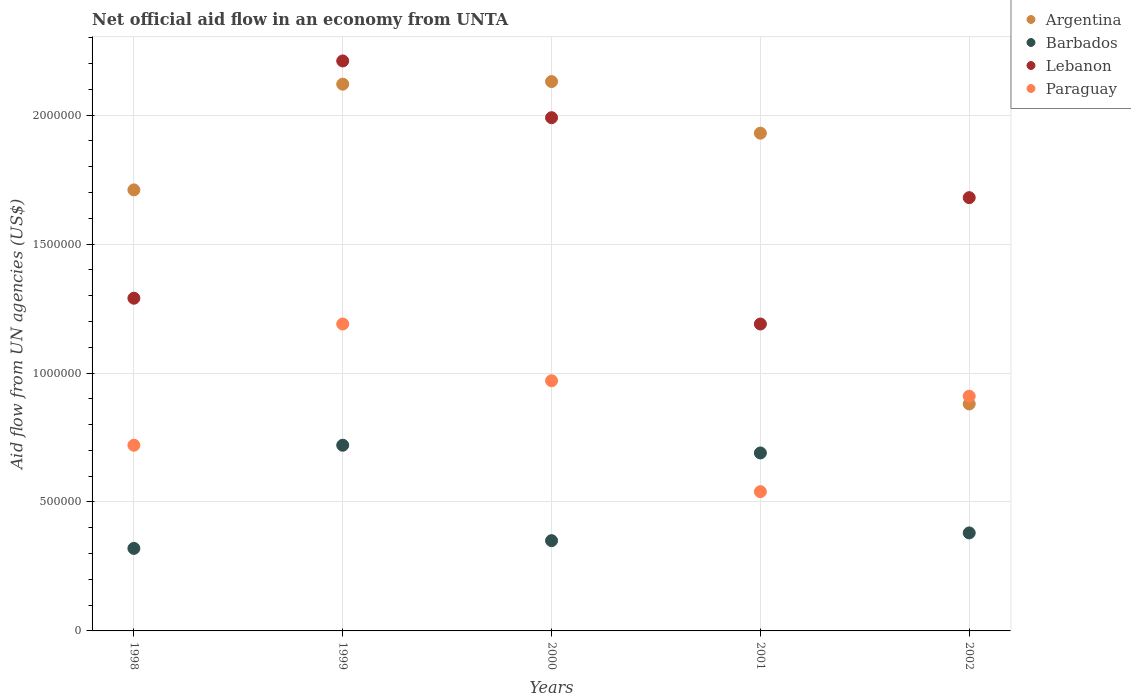Is the number of dotlines equal to the number of legend labels?
Keep it short and to the point. Yes. What is the net official aid flow in Paraguay in 2000?
Ensure brevity in your answer.  9.70e+05. Across all years, what is the maximum net official aid flow in Paraguay?
Ensure brevity in your answer.  1.19e+06. Across all years, what is the minimum net official aid flow in Paraguay?
Provide a succinct answer. 5.40e+05. In which year was the net official aid flow in Barbados minimum?
Make the answer very short. 1998. What is the total net official aid flow in Argentina in the graph?
Ensure brevity in your answer.  8.77e+06. What is the difference between the net official aid flow in Lebanon in 1998 and that in 2002?
Keep it short and to the point. -3.90e+05. What is the difference between the net official aid flow in Barbados in 2002 and the net official aid flow in Paraguay in 2000?
Give a very brief answer. -5.90e+05. What is the average net official aid flow in Argentina per year?
Ensure brevity in your answer.  1.75e+06. In the year 1998, what is the difference between the net official aid flow in Lebanon and net official aid flow in Argentina?
Make the answer very short. -4.20e+05. What is the ratio of the net official aid flow in Barbados in 2000 to that in 2002?
Provide a succinct answer. 0.92. Is the net official aid flow in Barbados in 2001 less than that in 2002?
Provide a short and direct response. No. Is the difference between the net official aid flow in Lebanon in 1998 and 2001 greater than the difference between the net official aid flow in Argentina in 1998 and 2001?
Give a very brief answer. Yes. What is the difference between the highest and the second highest net official aid flow in Lebanon?
Your answer should be compact. 2.20e+05. What is the difference between the highest and the lowest net official aid flow in Lebanon?
Your response must be concise. 1.02e+06. In how many years, is the net official aid flow in Argentina greater than the average net official aid flow in Argentina taken over all years?
Your answer should be very brief. 3. Is it the case that in every year, the sum of the net official aid flow in Argentina and net official aid flow in Barbados  is greater than the net official aid flow in Lebanon?
Provide a succinct answer. No. Is the net official aid flow in Barbados strictly greater than the net official aid flow in Argentina over the years?
Your response must be concise. No. Does the graph contain any zero values?
Offer a very short reply. No. Where does the legend appear in the graph?
Ensure brevity in your answer.  Top right. What is the title of the graph?
Keep it short and to the point. Net official aid flow in an economy from UNTA. What is the label or title of the X-axis?
Your response must be concise. Years. What is the label or title of the Y-axis?
Provide a short and direct response. Aid flow from UN agencies (US$). What is the Aid flow from UN agencies (US$) of Argentina in 1998?
Offer a very short reply. 1.71e+06. What is the Aid flow from UN agencies (US$) of Lebanon in 1998?
Offer a terse response. 1.29e+06. What is the Aid flow from UN agencies (US$) in Paraguay in 1998?
Your response must be concise. 7.20e+05. What is the Aid flow from UN agencies (US$) in Argentina in 1999?
Provide a succinct answer. 2.12e+06. What is the Aid flow from UN agencies (US$) of Barbados in 1999?
Make the answer very short. 7.20e+05. What is the Aid flow from UN agencies (US$) of Lebanon in 1999?
Keep it short and to the point. 2.21e+06. What is the Aid flow from UN agencies (US$) in Paraguay in 1999?
Your response must be concise. 1.19e+06. What is the Aid flow from UN agencies (US$) in Argentina in 2000?
Ensure brevity in your answer.  2.13e+06. What is the Aid flow from UN agencies (US$) of Lebanon in 2000?
Provide a succinct answer. 1.99e+06. What is the Aid flow from UN agencies (US$) in Paraguay in 2000?
Your answer should be compact. 9.70e+05. What is the Aid flow from UN agencies (US$) of Argentina in 2001?
Provide a short and direct response. 1.93e+06. What is the Aid flow from UN agencies (US$) in Barbados in 2001?
Make the answer very short. 6.90e+05. What is the Aid flow from UN agencies (US$) of Lebanon in 2001?
Your answer should be very brief. 1.19e+06. What is the Aid flow from UN agencies (US$) in Paraguay in 2001?
Provide a short and direct response. 5.40e+05. What is the Aid flow from UN agencies (US$) in Argentina in 2002?
Give a very brief answer. 8.80e+05. What is the Aid flow from UN agencies (US$) in Lebanon in 2002?
Provide a succinct answer. 1.68e+06. What is the Aid flow from UN agencies (US$) in Paraguay in 2002?
Your answer should be compact. 9.10e+05. Across all years, what is the maximum Aid flow from UN agencies (US$) in Argentina?
Give a very brief answer. 2.13e+06. Across all years, what is the maximum Aid flow from UN agencies (US$) in Barbados?
Make the answer very short. 7.20e+05. Across all years, what is the maximum Aid flow from UN agencies (US$) of Lebanon?
Offer a terse response. 2.21e+06. Across all years, what is the maximum Aid flow from UN agencies (US$) in Paraguay?
Provide a succinct answer. 1.19e+06. Across all years, what is the minimum Aid flow from UN agencies (US$) in Argentina?
Your answer should be very brief. 8.80e+05. Across all years, what is the minimum Aid flow from UN agencies (US$) of Lebanon?
Ensure brevity in your answer.  1.19e+06. Across all years, what is the minimum Aid flow from UN agencies (US$) in Paraguay?
Ensure brevity in your answer.  5.40e+05. What is the total Aid flow from UN agencies (US$) of Argentina in the graph?
Your answer should be very brief. 8.77e+06. What is the total Aid flow from UN agencies (US$) in Barbados in the graph?
Ensure brevity in your answer.  2.46e+06. What is the total Aid flow from UN agencies (US$) in Lebanon in the graph?
Provide a short and direct response. 8.36e+06. What is the total Aid flow from UN agencies (US$) in Paraguay in the graph?
Offer a terse response. 4.33e+06. What is the difference between the Aid flow from UN agencies (US$) in Argentina in 1998 and that in 1999?
Provide a succinct answer. -4.10e+05. What is the difference between the Aid flow from UN agencies (US$) in Barbados in 1998 and that in 1999?
Give a very brief answer. -4.00e+05. What is the difference between the Aid flow from UN agencies (US$) in Lebanon in 1998 and that in 1999?
Your response must be concise. -9.20e+05. What is the difference between the Aid flow from UN agencies (US$) of Paraguay in 1998 and that in 1999?
Give a very brief answer. -4.70e+05. What is the difference between the Aid flow from UN agencies (US$) of Argentina in 1998 and that in 2000?
Make the answer very short. -4.20e+05. What is the difference between the Aid flow from UN agencies (US$) in Barbados in 1998 and that in 2000?
Your answer should be very brief. -3.00e+04. What is the difference between the Aid flow from UN agencies (US$) of Lebanon in 1998 and that in 2000?
Keep it short and to the point. -7.00e+05. What is the difference between the Aid flow from UN agencies (US$) in Argentina in 1998 and that in 2001?
Provide a short and direct response. -2.20e+05. What is the difference between the Aid flow from UN agencies (US$) of Barbados in 1998 and that in 2001?
Give a very brief answer. -3.70e+05. What is the difference between the Aid flow from UN agencies (US$) in Lebanon in 1998 and that in 2001?
Give a very brief answer. 1.00e+05. What is the difference between the Aid flow from UN agencies (US$) of Argentina in 1998 and that in 2002?
Provide a succinct answer. 8.30e+05. What is the difference between the Aid flow from UN agencies (US$) of Barbados in 1998 and that in 2002?
Provide a succinct answer. -6.00e+04. What is the difference between the Aid flow from UN agencies (US$) of Lebanon in 1998 and that in 2002?
Keep it short and to the point. -3.90e+05. What is the difference between the Aid flow from UN agencies (US$) in Lebanon in 1999 and that in 2000?
Provide a short and direct response. 2.20e+05. What is the difference between the Aid flow from UN agencies (US$) in Paraguay in 1999 and that in 2000?
Your response must be concise. 2.20e+05. What is the difference between the Aid flow from UN agencies (US$) of Barbados in 1999 and that in 2001?
Your answer should be very brief. 3.00e+04. What is the difference between the Aid flow from UN agencies (US$) of Lebanon in 1999 and that in 2001?
Keep it short and to the point. 1.02e+06. What is the difference between the Aid flow from UN agencies (US$) of Paraguay in 1999 and that in 2001?
Give a very brief answer. 6.50e+05. What is the difference between the Aid flow from UN agencies (US$) of Argentina in 1999 and that in 2002?
Offer a terse response. 1.24e+06. What is the difference between the Aid flow from UN agencies (US$) in Barbados in 1999 and that in 2002?
Offer a terse response. 3.40e+05. What is the difference between the Aid flow from UN agencies (US$) in Lebanon in 1999 and that in 2002?
Offer a very short reply. 5.30e+05. What is the difference between the Aid flow from UN agencies (US$) of Paraguay in 1999 and that in 2002?
Offer a terse response. 2.80e+05. What is the difference between the Aid flow from UN agencies (US$) in Argentina in 2000 and that in 2001?
Ensure brevity in your answer.  2.00e+05. What is the difference between the Aid flow from UN agencies (US$) of Barbados in 2000 and that in 2001?
Your answer should be very brief. -3.40e+05. What is the difference between the Aid flow from UN agencies (US$) of Lebanon in 2000 and that in 2001?
Ensure brevity in your answer.  8.00e+05. What is the difference between the Aid flow from UN agencies (US$) of Argentina in 2000 and that in 2002?
Ensure brevity in your answer.  1.25e+06. What is the difference between the Aid flow from UN agencies (US$) in Argentina in 2001 and that in 2002?
Ensure brevity in your answer.  1.05e+06. What is the difference between the Aid flow from UN agencies (US$) in Lebanon in 2001 and that in 2002?
Your answer should be very brief. -4.90e+05. What is the difference between the Aid flow from UN agencies (US$) in Paraguay in 2001 and that in 2002?
Your response must be concise. -3.70e+05. What is the difference between the Aid flow from UN agencies (US$) in Argentina in 1998 and the Aid flow from UN agencies (US$) in Barbados in 1999?
Your answer should be compact. 9.90e+05. What is the difference between the Aid flow from UN agencies (US$) of Argentina in 1998 and the Aid flow from UN agencies (US$) of Lebanon in 1999?
Offer a very short reply. -5.00e+05. What is the difference between the Aid flow from UN agencies (US$) in Argentina in 1998 and the Aid flow from UN agencies (US$) in Paraguay in 1999?
Your answer should be very brief. 5.20e+05. What is the difference between the Aid flow from UN agencies (US$) in Barbados in 1998 and the Aid flow from UN agencies (US$) in Lebanon in 1999?
Ensure brevity in your answer.  -1.89e+06. What is the difference between the Aid flow from UN agencies (US$) in Barbados in 1998 and the Aid flow from UN agencies (US$) in Paraguay in 1999?
Provide a short and direct response. -8.70e+05. What is the difference between the Aid flow from UN agencies (US$) of Lebanon in 1998 and the Aid flow from UN agencies (US$) of Paraguay in 1999?
Your answer should be very brief. 1.00e+05. What is the difference between the Aid flow from UN agencies (US$) of Argentina in 1998 and the Aid flow from UN agencies (US$) of Barbados in 2000?
Your answer should be very brief. 1.36e+06. What is the difference between the Aid flow from UN agencies (US$) of Argentina in 1998 and the Aid flow from UN agencies (US$) of Lebanon in 2000?
Give a very brief answer. -2.80e+05. What is the difference between the Aid flow from UN agencies (US$) in Argentina in 1998 and the Aid flow from UN agencies (US$) in Paraguay in 2000?
Make the answer very short. 7.40e+05. What is the difference between the Aid flow from UN agencies (US$) of Barbados in 1998 and the Aid flow from UN agencies (US$) of Lebanon in 2000?
Your response must be concise. -1.67e+06. What is the difference between the Aid flow from UN agencies (US$) of Barbados in 1998 and the Aid flow from UN agencies (US$) of Paraguay in 2000?
Keep it short and to the point. -6.50e+05. What is the difference between the Aid flow from UN agencies (US$) in Lebanon in 1998 and the Aid flow from UN agencies (US$) in Paraguay in 2000?
Provide a short and direct response. 3.20e+05. What is the difference between the Aid flow from UN agencies (US$) of Argentina in 1998 and the Aid flow from UN agencies (US$) of Barbados in 2001?
Provide a succinct answer. 1.02e+06. What is the difference between the Aid flow from UN agencies (US$) in Argentina in 1998 and the Aid flow from UN agencies (US$) in Lebanon in 2001?
Your response must be concise. 5.20e+05. What is the difference between the Aid flow from UN agencies (US$) of Argentina in 1998 and the Aid flow from UN agencies (US$) of Paraguay in 2001?
Offer a terse response. 1.17e+06. What is the difference between the Aid flow from UN agencies (US$) of Barbados in 1998 and the Aid flow from UN agencies (US$) of Lebanon in 2001?
Your answer should be compact. -8.70e+05. What is the difference between the Aid flow from UN agencies (US$) of Lebanon in 1998 and the Aid flow from UN agencies (US$) of Paraguay in 2001?
Offer a very short reply. 7.50e+05. What is the difference between the Aid flow from UN agencies (US$) in Argentina in 1998 and the Aid flow from UN agencies (US$) in Barbados in 2002?
Make the answer very short. 1.33e+06. What is the difference between the Aid flow from UN agencies (US$) in Argentina in 1998 and the Aid flow from UN agencies (US$) in Lebanon in 2002?
Keep it short and to the point. 3.00e+04. What is the difference between the Aid flow from UN agencies (US$) in Barbados in 1998 and the Aid flow from UN agencies (US$) in Lebanon in 2002?
Provide a short and direct response. -1.36e+06. What is the difference between the Aid flow from UN agencies (US$) in Barbados in 1998 and the Aid flow from UN agencies (US$) in Paraguay in 2002?
Provide a short and direct response. -5.90e+05. What is the difference between the Aid flow from UN agencies (US$) in Lebanon in 1998 and the Aid flow from UN agencies (US$) in Paraguay in 2002?
Give a very brief answer. 3.80e+05. What is the difference between the Aid flow from UN agencies (US$) in Argentina in 1999 and the Aid flow from UN agencies (US$) in Barbados in 2000?
Keep it short and to the point. 1.77e+06. What is the difference between the Aid flow from UN agencies (US$) in Argentina in 1999 and the Aid flow from UN agencies (US$) in Lebanon in 2000?
Provide a succinct answer. 1.30e+05. What is the difference between the Aid flow from UN agencies (US$) of Argentina in 1999 and the Aid flow from UN agencies (US$) of Paraguay in 2000?
Your answer should be compact. 1.15e+06. What is the difference between the Aid flow from UN agencies (US$) in Barbados in 1999 and the Aid flow from UN agencies (US$) in Lebanon in 2000?
Give a very brief answer. -1.27e+06. What is the difference between the Aid flow from UN agencies (US$) in Barbados in 1999 and the Aid flow from UN agencies (US$) in Paraguay in 2000?
Make the answer very short. -2.50e+05. What is the difference between the Aid flow from UN agencies (US$) in Lebanon in 1999 and the Aid flow from UN agencies (US$) in Paraguay in 2000?
Provide a short and direct response. 1.24e+06. What is the difference between the Aid flow from UN agencies (US$) of Argentina in 1999 and the Aid flow from UN agencies (US$) of Barbados in 2001?
Offer a terse response. 1.43e+06. What is the difference between the Aid flow from UN agencies (US$) of Argentina in 1999 and the Aid flow from UN agencies (US$) of Lebanon in 2001?
Provide a succinct answer. 9.30e+05. What is the difference between the Aid flow from UN agencies (US$) in Argentina in 1999 and the Aid flow from UN agencies (US$) in Paraguay in 2001?
Offer a terse response. 1.58e+06. What is the difference between the Aid flow from UN agencies (US$) in Barbados in 1999 and the Aid flow from UN agencies (US$) in Lebanon in 2001?
Your response must be concise. -4.70e+05. What is the difference between the Aid flow from UN agencies (US$) of Lebanon in 1999 and the Aid flow from UN agencies (US$) of Paraguay in 2001?
Make the answer very short. 1.67e+06. What is the difference between the Aid flow from UN agencies (US$) in Argentina in 1999 and the Aid flow from UN agencies (US$) in Barbados in 2002?
Offer a terse response. 1.74e+06. What is the difference between the Aid flow from UN agencies (US$) in Argentina in 1999 and the Aid flow from UN agencies (US$) in Lebanon in 2002?
Ensure brevity in your answer.  4.40e+05. What is the difference between the Aid flow from UN agencies (US$) of Argentina in 1999 and the Aid flow from UN agencies (US$) of Paraguay in 2002?
Your answer should be very brief. 1.21e+06. What is the difference between the Aid flow from UN agencies (US$) of Barbados in 1999 and the Aid flow from UN agencies (US$) of Lebanon in 2002?
Provide a succinct answer. -9.60e+05. What is the difference between the Aid flow from UN agencies (US$) of Barbados in 1999 and the Aid flow from UN agencies (US$) of Paraguay in 2002?
Make the answer very short. -1.90e+05. What is the difference between the Aid flow from UN agencies (US$) in Lebanon in 1999 and the Aid flow from UN agencies (US$) in Paraguay in 2002?
Provide a short and direct response. 1.30e+06. What is the difference between the Aid flow from UN agencies (US$) of Argentina in 2000 and the Aid flow from UN agencies (US$) of Barbados in 2001?
Your answer should be very brief. 1.44e+06. What is the difference between the Aid flow from UN agencies (US$) in Argentina in 2000 and the Aid flow from UN agencies (US$) in Lebanon in 2001?
Give a very brief answer. 9.40e+05. What is the difference between the Aid flow from UN agencies (US$) of Argentina in 2000 and the Aid flow from UN agencies (US$) of Paraguay in 2001?
Your response must be concise. 1.59e+06. What is the difference between the Aid flow from UN agencies (US$) of Barbados in 2000 and the Aid flow from UN agencies (US$) of Lebanon in 2001?
Your answer should be very brief. -8.40e+05. What is the difference between the Aid flow from UN agencies (US$) in Lebanon in 2000 and the Aid flow from UN agencies (US$) in Paraguay in 2001?
Provide a succinct answer. 1.45e+06. What is the difference between the Aid flow from UN agencies (US$) of Argentina in 2000 and the Aid flow from UN agencies (US$) of Barbados in 2002?
Offer a terse response. 1.75e+06. What is the difference between the Aid flow from UN agencies (US$) of Argentina in 2000 and the Aid flow from UN agencies (US$) of Lebanon in 2002?
Offer a very short reply. 4.50e+05. What is the difference between the Aid flow from UN agencies (US$) of Argentina in 2000 and the Aid flow from UN agencies (US$) of Paraguay in 2002?
Keep it short and to the point. 1.22e+06. What is the difference between the Aid flow from UN agencies (US$) in Barbados in 2000 and the Aid flow from UN agencies (US$) in Lebanon in 2002?
Your response must be concise. -1.33e+06. What is the difference between the Aid flow from UN agencies (US$) of Barbados in 2000 and the Aid flow from UN agencies (US$) of Paraguay in 2002?
Give a very brief answer. -5.60e+05. What is the difference between the Aid flow from UN agencies (US$) in Lebanon in 2000 and the Aid flow from UN agencies (US$) in Paraguay in 2002?
Give a very brief answer. 1.08e+06. What is the difference between the Aid flow from UN agencies (US$) in Argentina in 2001 and the Aid flow from UN agencies (US$) in Barbados in 2002?
Make the answer very short. 1.55e+06. What is the difference between the Aid flow from UN agencies (US$) of Argentina in 2001 and the Aid flow from UN agencies (US$) of Paraguay in 2002?
Your answer should be very brief. 1.02e+06. What is the difference between the Aid flow from UN agencies (US$) in Barbados in 2001 and the Aid flow from UN agencies (US$) in Lebanon in 2002?
Keep it short and to the point. -9.90e+05. What is the average Aid flow from UN agencies (US$) of Argentina per year?
Ensure brevity in your answer.  1.75e+06. What is the average Aid flow from UN agencies (US$) in Barbados per year?
Keep it short and to the point. 4.92e+05. What is the average Aid flow from UN agencies (US$) of Lebanon per year?
Provide a short and direct response. 1.67e+06. What is the average Aid flow from UN agencies (US$) in Paraguay per year?
Offer a very short reply. 8.66e+05. In the year 1998, what is the difference between the Aid flow from UN agencies (US$) of Argentina and Aid flow from UN agencies (US$) of Barbados?
Provide a succinct answer. 1.39e+06. In the year 1998, what is the difference between the Aid flow from UN agencies (US$) in Argentina and Aid flow from UN agencies (US$) in Lebanon?
Provide a succinct answer. 4.20e+05. In the year 1998, what is the difference between the Aid flow from UN agencies (US$) of Argentina and Aid flow from UN agencies (US$) of Paraguay?
Make the answer very short. 9.90e+05. In the year 1998, what is the difference between the Aid flow from UN agencies (US$) of Barbados and Aid flow from UN agencies (US$) of Lebanon?
Keep it short and to the point. -9.70e+05. In the year 1998, what is the difference between the Aid flow from UN agencies (US$) in Barbados and Aid flow from UN agencies (US$) in Paraguay?
Make the answer very short. -4.00e+05. In the year 1998, what is the difference between the Aid flow from UN agencies (US$) of Lebanon and Aid flow from UN agencies (US$) of Paraguay?
Ensure brevity in your answer.  5.70e+05. In the year 1999, what is the difference between the Aid flow from UN agencies (US$) in Argentina and Aid flow from UN agencies (US$) in Barbados?
Provide a succinct answer. 1.40e+06. In the year 1999, what is the difference between the Aid flow from UN agencies (US$) in Argentina and Aid flow from UN agencies (US$) in Paraguay?
Give a very brief answer. 9.30e+05. In the year 1999, what is the difference between the Aid flow from UN agencies (US$) of Barbados and Aid flow from UN agencies (US$) of Lebanon?
Your answer should be compact. -1.49e+06. In the year 1999, what is the difference between the Aid flow from UN agencies (US$) in Barbados and Aid flow from UN agencies (US$) in Paraguay?
Your answer should be compact. -4.70e+05. In the year 1999, what is the difference between the Aid flow from UN agencies (US$) in Lebanon and Aid flow from UN agencies (US$) in Paraguay?
Keep it short and to the point. 1.02e+06. In the year 2000, what is the difference between the Aid flow from UN agencies (US$) of Argentina and Aid flow from UN agencies (US$) of Barbados?
Offer a terse response. 1.78e+06. In the year 2000, what is the difference between the Aid flow from UN agencies (US$) of Argentina and Aid flow from UN agencies (US$) of Paraguay?
Give a very brief answer. 1.16e+06. In the year 2000, what is the difference between the Aid flow from UN agencies (US$) of Barbados and Aid flow from UN agencies (US$) of Lebanon?
Give a very brief answer. -1.64e+06. In the year 2000, what is the difference between the Aid flow from UN agencies (US$) in Barbados and Aid flow from UN agencies (US$) in Paraguay?
Keep it short and to the point. -6.20e+05. In the year 2000, what is the difference between the Aid flow from UN agencies (US$) of Lebanon and Aid flow from UN agencies (US$) of Paraguay?
Offer a terse response. 1.02e+06. In the year 2001, what is the difference between the Aid flow from UN agencies (US$) of Argentina and Aid flow from UN agencies (US$) of Barbados?
Provide a short and direct response. 1.24e+06. In the year 2001, what is the difference between the Aid flow from UN agencies (US$) of Argentina and Aid flow from UN agencies (US$) of Lebanon?
Keep it short and to the point. 7.40e+05. In the year 2001, what is the difference between the Aid flow from UN agencies (US$) of Argentina and Aid flow from UN agencies (US$) of Paraguay?
Your answer should be very brief. 1.39e+06. In the year 2001, what is the difference between the Aid flow from UN agencies (US$) in Barbados and Aid flow from UN agencies (US$) in Lebanon?
Offer a terse response. -5.00e+05. In the year 2001, what is the difference between the Aid flow from UN agencies (US$) of Barbados and Aid flow from UN agencies (US$) of Paraguay?
Offer a terse response. 1.50e+05. In the year 2001, what is the difference between the Aid flow from UN agencies (US$) in Lebanon and Aid flow from UN agencies (US$) in Paraguay?
Provide a short and direct response. 6.50e+05. In the year 2002, what is the difference between the Aid flow from UN agencies (US$) of Argentina and Aid flow from UN agencies (US$) of Lebanon?
Make the answer very short. -8.00e+05. In the year 2002, what is the difference between the Aid flow from UN agencies (US$) of Argentina and Aid flow from UN agencies (US$) of Paraguay?
Give a very brief answer. -3.00e+04. In the year 2002, what is the difference between the Aid flow from UN agencies (US$) of Barbados and Aid flow from UN agencies (US$) of Lebanon?
Ensure brevity in your answer.  -1.30e+06. In the year 2002, what is the difference between the Aid flow from UN agencies (US$) of Barbados and Aid flow from UN agencies (US$) of Paraguay?
Your answer should be very brief. -5.30e+05. In the year 2002, what is the difference between the Aid flow from UN agencies (US$) of Lebanon and Aid flow from UN agencies (US$) of Paraguay?
Keep it short and to the point. 7.70e+05. What is the ratio of the Aid flow from UN agencies (US$) of Argentina in 1998 to that in 1999?
Ensure brevity in your answer.  0.81. What is the ratio of the Aid flow from UN agencies (US$) in Barbados in 1998 to that in 1999?
Offer a terse response. 0.44. What is the ratio of the Aid flow from UN agencies (US$) in Lebanon in 1998 to that in 1999?
Provide a short and direct response. 0.58. What is the ratio of the Aid flow from UN agencies (US$) in Paraguay in 1998 to that in 1999?
Make the answer very short. 0.6. What is the ratio of the Aid flow from UN agencies (US$) in Argentina in 1998 to that in 2000?
Keep it short and to the point. 0.8. What is the ratio of the Aid flow from UN agencies (US$) of Barbados in 1998 to that in 2000?
Offer a terse response. 0.91. What is the ratio of the Aid flow from UN agencies (US$) of Lebanon in 1998 to that in 2000?
Offer a very short reply. 0.65. What is the ratio of the Aid flow from UN agencies (US$) in Paraguay in 1998 to that in 2000?
Your answer should be very brief. 0.74. What is the ratio of the Aid flow from UN agencies (US$) in Argentina in 1998 to that in 2001?
Give a very brief answer. 0.89. What is the ratio of the Aid flow from UN agencies (US$) of Barbados in 1998 to that in 2001?
Make the answer very short. 0.46. What is the ratio of the Aid flow from UN agencies (US$) of Lebanon in 1998 to that in 2001?
Offer a terse response. 1.08. What is the ratio of the Aid flow from UN agencies (US$) in Argentina in 1998 to that in 2002?
Keep it short and to the point. 1.94. What is the ratio of the Aid flow from UN agencies (US$) in Barbados in 1998 to that in 2002?
Make the answer very short. 0.84. What is the ratio of the Aid flow from UN agencies (US$) in Lebanon in 1998 to that in 2002?
Make the answer very short. 0.77. What is the ratio of the Aid flow from UN agencies (US$) of Paraguay in 1998 to that in 2002?
Make the answer very short. 0.79. What is the ratio of the Aid flow from UN agencies (US$) of Barbados in 1999 to that in 2000?
Provide a succinct answer. 2.06. What is the ratio of the Aid flow from UN agencies (US$) of Lebanon in 1999 to that in 2000?
Offer a very short reply. 1.11. What is the ratio of the Aid flow from UN agencies (US$) of Paraguay in 1999 to that in 2000?
Give a very brief answer. 1.23. What is the ratio of the Aid flow from UN agencies (US$) of Argentina in 1999 to that in 2001?
Your answer should be compact. 1.1. What is the ratio of the Aid flow from UN agencies (US$) of Barbados in 1999 to that in 2001?
Make the answer very short. 1.04. What is the ratio of the Aid flow from UN agencies (US$) in Lebanon in 1999 to that in 2001?
Provide a short and direct response. 1.86. What is the ratio of the Aid flow from UN agencies (US$) of Paraguay in 1999 to that in 2001?
Offer a terse response. 2.2. What is the ratio of the Aid flow from UN agencies (US$) in Argentina in 1999 to that in 2002?
Your answer should be very brief. 2.41. What is the ratio of the Aid flow from UN agencies (US$) in Barbados in 1999 to that in 2002?
Provide a succinct answer. 1.89. What is the ratio of the Aid flow from UN agencies (US$) of Lebanon in 1999 to that in 2002?
Ensure brevity in your answer.  1.32. What is the ratio of the Aid flow from UN agencies (US$) of Paraguay in 1999 to that in 2002?
Offer a very short reply. 1.31. What is the ratio of the Aid flow from UN agencies (US$) in Argentina in 2000 to that in 2001?
Provide a short and direct response. 1.1. What is the ratio of the Aid flow from UN agencies (US$) of Barbados in 2000 to that in 2001?
Your response must be concise. 0.51. What is the ratio of the Aid flow from UN agencies (US$) of Lebanon in 2000 to that in 2001?
Provide a short and direct response. 1.67. What is the ratio of the Aid flow from UN agencies (US$) in Paraguay in 2000 to that in 2001?
Give a very brief answer. 1.8. What is the ratio of the Aid flow from UN agencies (US$) of Argentina in 2000 to that in 2002?
Ensure brevity in your answer.  2.42. What is the ratio of the Aid flow from UN agencies (US$) in Barbados in 2000 to that in 2002?
Provide a succinct answer. 0.92. What is the ratio of the Aid flow from UN agencies (US$) of Lebanon in 2000 to that in 2002?
Provide a short and direct response. 1.18. What is the ratio of the Aid flow from UN agencies (US$) of Paraguay in 2000 to that in 2002?
Your response must be concise. 1.07. What is the ratio of the Aid flow from UN agencies (US$) of Argentina in 2001 to that in 2002?
Give a very brief answer. 2.19. What is the ratio of the Aid flow from UN agencies (US$) in Barbados in 2001 to that in 2002?
Ensure brevity in your answer.  1.82. What is the ratio of the Aid flow from UN agencies (US$) in Lebanon in 2001 to that in 2002?
Your answer should be very brief. 0.71. What is the ratio of the Aid flow from UN agencies (US$) of Paraguay in 2001 to that in 2002?
Keep it short and to the point. 0.59. What is the difference between the highest and the second highest Aid flow from UN agencies (US$) in Argentina?
Offer a very short reply. 10000. What is the difference between the highest and the second highest Aid flow from UN agencies (US$) of Paraguay?
Provide a succinct answer. 2.20e+05. What is the difference between the highest and the lowest Aid flow from UN agencies (US$) in Argentina?
Your answer should be very brief. 1.25e+06. What is the difference between the highest and the lowest Aid flow from UN agencies (US$) of Lebanon?
Offer a terse response. 1.02e+06. What is the difference between the highest and the lowest Aid flow from UN agencies (US$) in Paraguay?
Your response must be concise. 6.50e+05. 